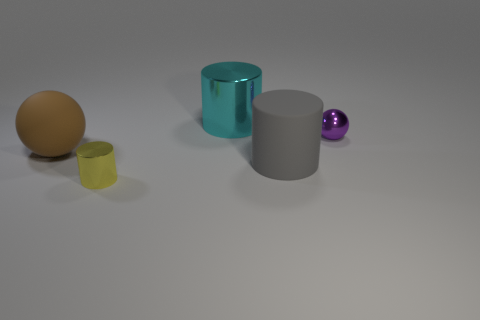What number of things are either tiny red rubber cubes or metallic objects on the right side of the yellow cylinder?
Provide a short and direct response. 2. There is a metal cylinder that is in front of the gray matte object; what size is it?
Offer a very short reply. Small. Are there fewer gray things that are in front of the small purple object than large metallic things that are in front of the yellow cylinder?
Your response must be concise. No. What material is the object that is both behind the matte cylinder and right of the big cyan cylinder?
Offer a very short reply. Metal. There is a large rubber thing in front of the large matte ball left of the tiny purple thing; what shape is it?
Provide a short and direct response. Cylinder. Is the color of the small sphere the same as the large metal thing?
Your answer should be compact. No. How many red things are either big matte spheres or small metal things?
Your answer should be compact. 0. There is a tiny cylinder; are there any small purple metal spheres left of it?
Make the answer very short. No. The brown thing is what size?
Your response must be concise. Large. There is another metallic thing that is the same shape as the small yellow metal object; what is its size?
Your response must be concise. Large. 